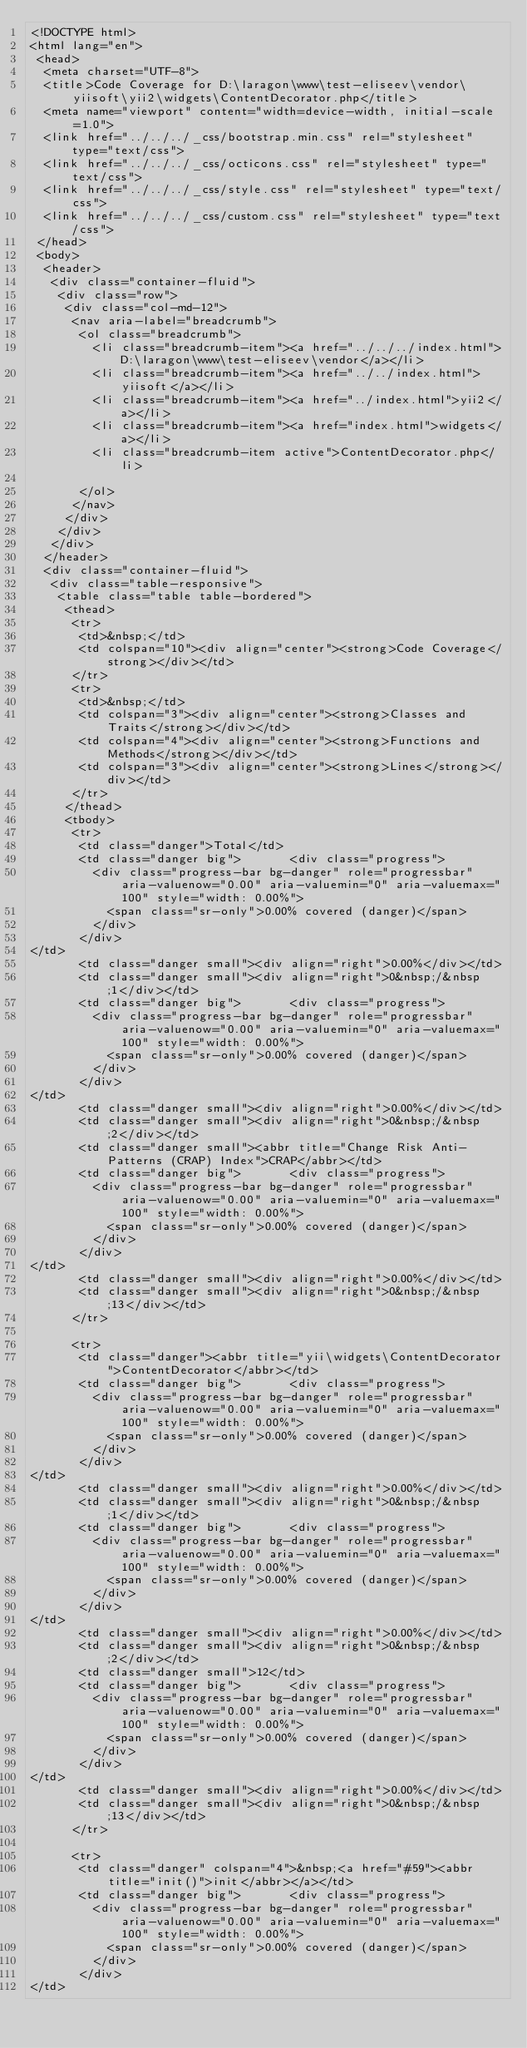<code> <loc_0><loc_0><loc_500><loc_500><_HTML_><!DOCTYPE html>
<html lang="en">
 <head>
  <meta charset="UTF-8">
  <title>Code Coverage for D:\laragon\www\test-eliseev\vendor\yiisoft\yii2\widgets\ContentDecorator.php</title>
  <meta name="viewport" content="width=device-width, initial-scale=1.0">
  <link href="../../../_css/bootstrap.min.css" rel="stylesheet" type="text/css">
  <link href="../../../_css/octicons.css" rel="stylesheet" type="text/css">
  <link href="../../../_css/style.css" rel="stylesheet" type="text/css">
  <link href="../../../_css/custom.css" rel="stylesheet" type="text/css">
 </head>
 <body>
  <header>
   <div class="container-fluid">
    <div class="row">
     <div class="col-md-12">
      <nav aria-label="breadcrumb">
       <ol class="breadcrumb">
         <li class="breadcrumb-item"><a href="../../../index.html">D:\laragon\www\test-eliseev\vendor</a></li>
         <li class="breadcrumb-item"><a href="../../index.html">yiisoft</a></li>
         <li class="breadcrumb-item"><a href="../index.html">yii2</a></li>
         <li class="breadcrumb-item"><a href="index.html">widgets</a></li>
         <li class="breadcrumb-item active">ContentDecorator.php</li>

       </ol>
      </nav>
     </div>
    </div>
   </div>
  </header>
  <div class="container-fluid">
   <div class="table-responsive">
    <table class="table table-bordered">
     <thead>
      <tr>
       <td>&nbsp;</td>
       <td colspan="10"><div align="center"><strong>Code Coverage</strong></div></td>
      </tr>
      <tr>
       <td>&nbsp;</td>
       <td colspan="3"><div align="center"><strong>Classes and Traits</strong></div></td>
       <td colspan="4"><div align="center"><strong>Functions and Methods</strong></div></td>
       <td colspan="3"><div align="center"><strong>Lines</strong></div></td>
      </tr>
     </thead>
     <tbody>
      <tr>
       <td class="danger">Total</td>
       <td class="danger big">       <div class="progress">
         <div class="progress-bar bg-danger" role="progressbar" aria-valuenow="0.00" aria-valuemin="0" aria-valuemax="100" style="width: 0.00%">
           <span class="sr-only">0.00% covered (danger)</span>
         </div>
       </div>
</td>
       <td class="danger small"><div align="right">0.00%</div></td>
       <td class="danger small"><div align="right">0&nbsp;/&nbsp;1</div></td>
       <td class="danger big">       <div class="progress">
         <div class="progress-bar bg-danger" role="progressbar" aria-valuenow="0.00" aria-valuemin="0" aria-valuemax="100" style="width: 0.00%">
           <span class="sr-only">0.00% covered (danger)</span>
         </div>
       </div>
</td>
       <td class="danger small"><div align="right">0.00%</div></td>
       <td class="danger small"><div align="right">0&nbsp;/&nbsp;2</div></td>
       <td class="danger small"><abbr title="Change Risk Anti-Patterns (CRAP) Index">CRAP</abbr></td>
       <td class="danger big">       <div class="progress">
         <div class="progress-bar bg-danger" role="progressbar" aria-valuenow="0.00" aria-valuemin="0" aria-valuemax="100" style="width: 0.00%">
           <span class="sr-only">0.00% covered (danger)</span>
         </div>
       </div>
</td>
       <td class="danger small"><div align="right">0.00%</div></td>
       <td class="danger small"><div align="right">0&nbsp;/&nbsp;13</div></td>
      </tr>

      <tr>
       <td class="danger"><abbr title="yii\widgets\ContentDecorator">ContentDecorator</abbr></td>
       <td class="danger big">       <div class="progress">
         <div class="progress-bar bg-danger" role="progressbar" aria-valuenow="0.00" aria-valuemin="0" aria-valuemax="100" style="width: 0.00%">
           <span class="sr-only">0.00% covered (danger)</span>
         </div>
       </div>
</td>
       <td class="danger small"><div align="right">0.00%</div></td>
       <td class="danger small"><div align="right">0&nbsp;/&nbsp;1</div></td>
       <td class="danger big">       <div class="progress">
         <div class="progress-bar bg-danger" role="progressbar" aria-valuenow="0.00" aria-valuemin="0" aria-valuemax="100" style="width: 0.00%">
           <span class="sr-only">0.00% covered (danger)</span>
         </div>
       </div>
</td>
       <td class="danger small"><div align="right">0.00%</div></td>
       <td class="danger small"><div align="right">0&nbsp;/&nbsp;2</div></td>
       <td class="danger small">12</td>
       <td class="danger big">       <div class="progress">
         <div class="progress-bar bg-danger" role="progressbar" aria-valuenow="0.00" aria-valuemin="0" aria-valuemax="100" style="width: 0.00%">
           <span class="sr-only">0.00% covered (danger)</span>
         </div>
       </div>
</td>
       <td class="danger small"><div align="right">0.00%</div></td>
       <td class="danger small"><div align="right">0&nbsp;/&nbsp;13</div></td>
      </tr>

      <tr>
       <td class="danger" colspan="4">&nbsp;<a href="#59"><abbr title="init()">init</abbr></a></td>
       <td class="danger big">       <div class="progress">
         <div class="progress-bar bg-danger" role="progressbar" aria-valuenow="0.00" aria-valuemin="0" aria-valuemax="100" style="width: 0.00%">
           <span class="sr-only">0.00% covered (danger)</span>
         </div>
       </div>
</td></code> 